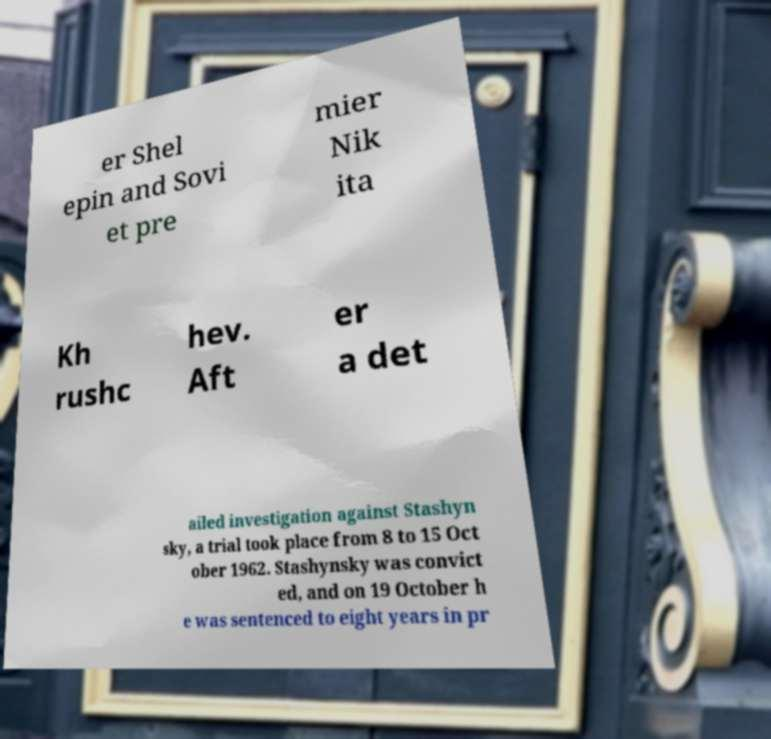I need the written content from this picture converted into text. Can you do that? er Shel epin and Sovi et pre mier Nik ita Kh rushc hev. Aft er a det ailed investigation against Stashyn sky, a trial took place from 8 to 15 Oct ober 1962. Stashynsky was convict ed, and on 19 October h e was sentenced to eight years in pr 